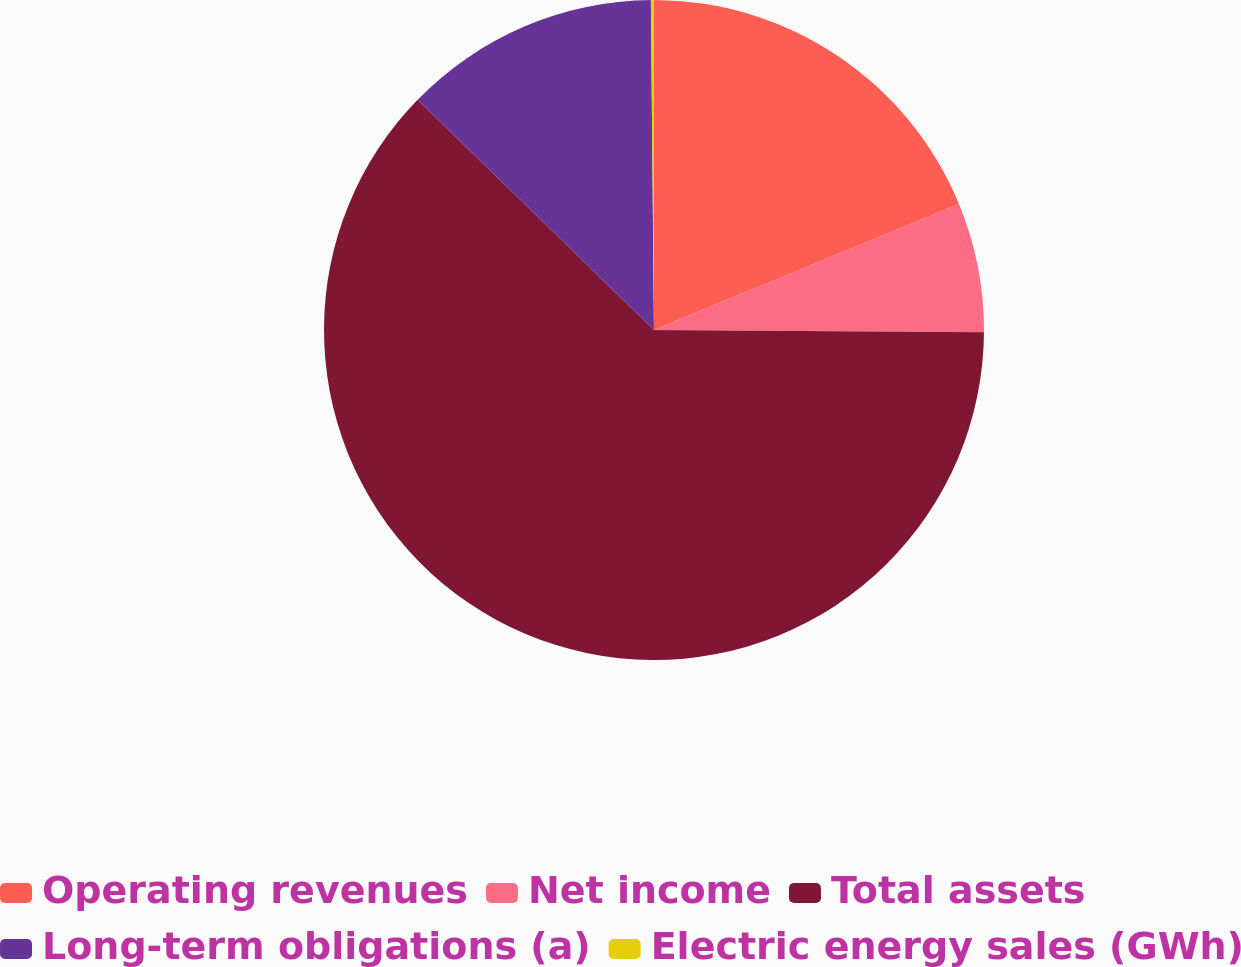Convert chart. <chart><loc_0><loc_0><loc_500><loc_500><pie_chart><fcel>Operating revenues<fcel>Net income<fcel>Total assets<fcel>Long-term obligations (a)<fcel>Electric energy sales (GWh)<nl><fcel>18.76%<fcel>6.35%<fcel>62.18%<fcel>12.56%<fcel>0.15%<nl></chart> 